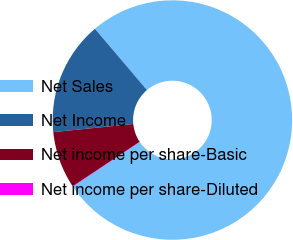<chart> <loc_0><loc_0><loc_500><loc_500><pie_chart><fcel>Net Sales<fcel>Net Income<fcel>Net income per share-Basic<fcel>Net income per share-Diluted<nl><fcel>76.8%<fcel>15.41%<fcel>7.73%<fcel>0.06%<nl></chart> 